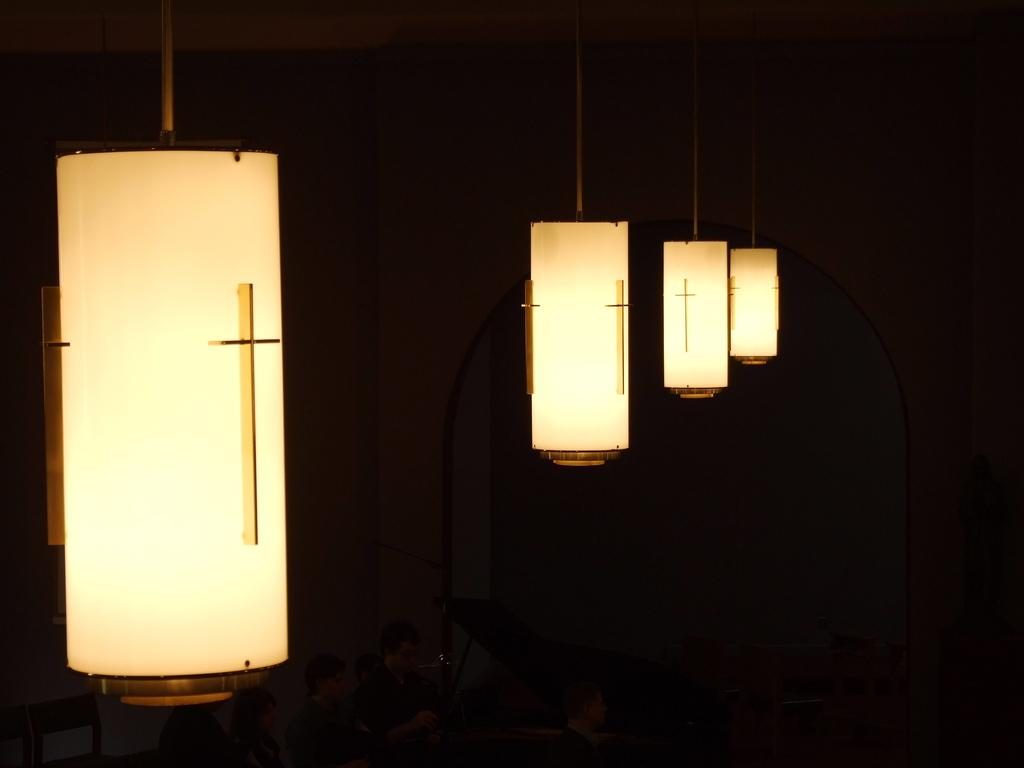What can be seen in the image that provides illumination? There are lights in the image. What are the people in the image doing? The people in the image are sitting at the bottom. Where is the toad located in the image? There is no toad present in the image. What type of map is being used by the people in the image? There is no map present in the image. 